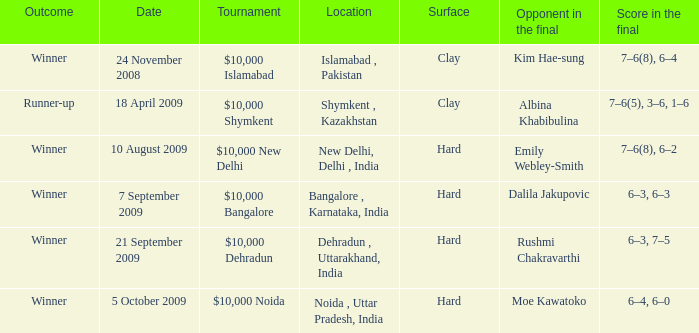What is the material of the surface in noida , uttar pradesh, india Hard. 